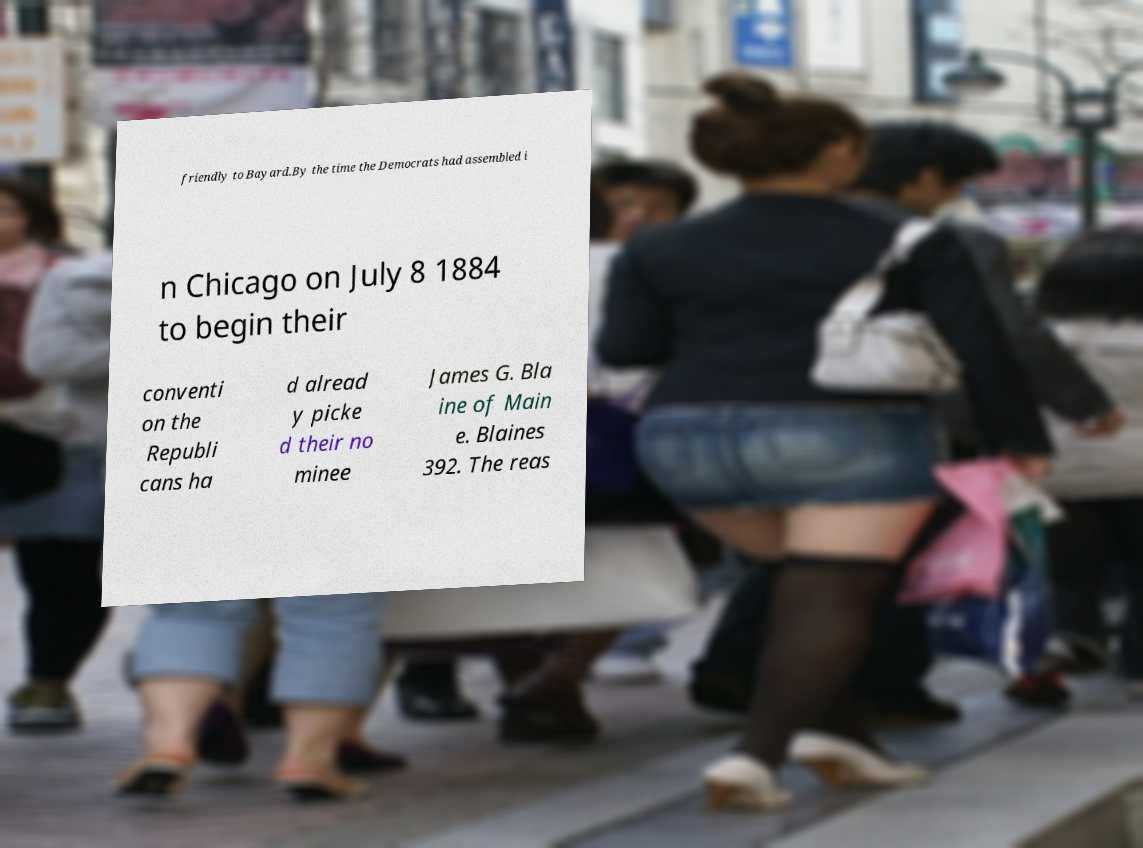What messages or text are displayed in this image? I need them in a readable, typed format. friendly to Bayard.By the time the Democrats had assembled i n Chicago on July 8 1884 to begin their conventi on the Republi cans ha d alread y picke d their no minee James G. Bla ine of Main e. Blaines 392. The reas 